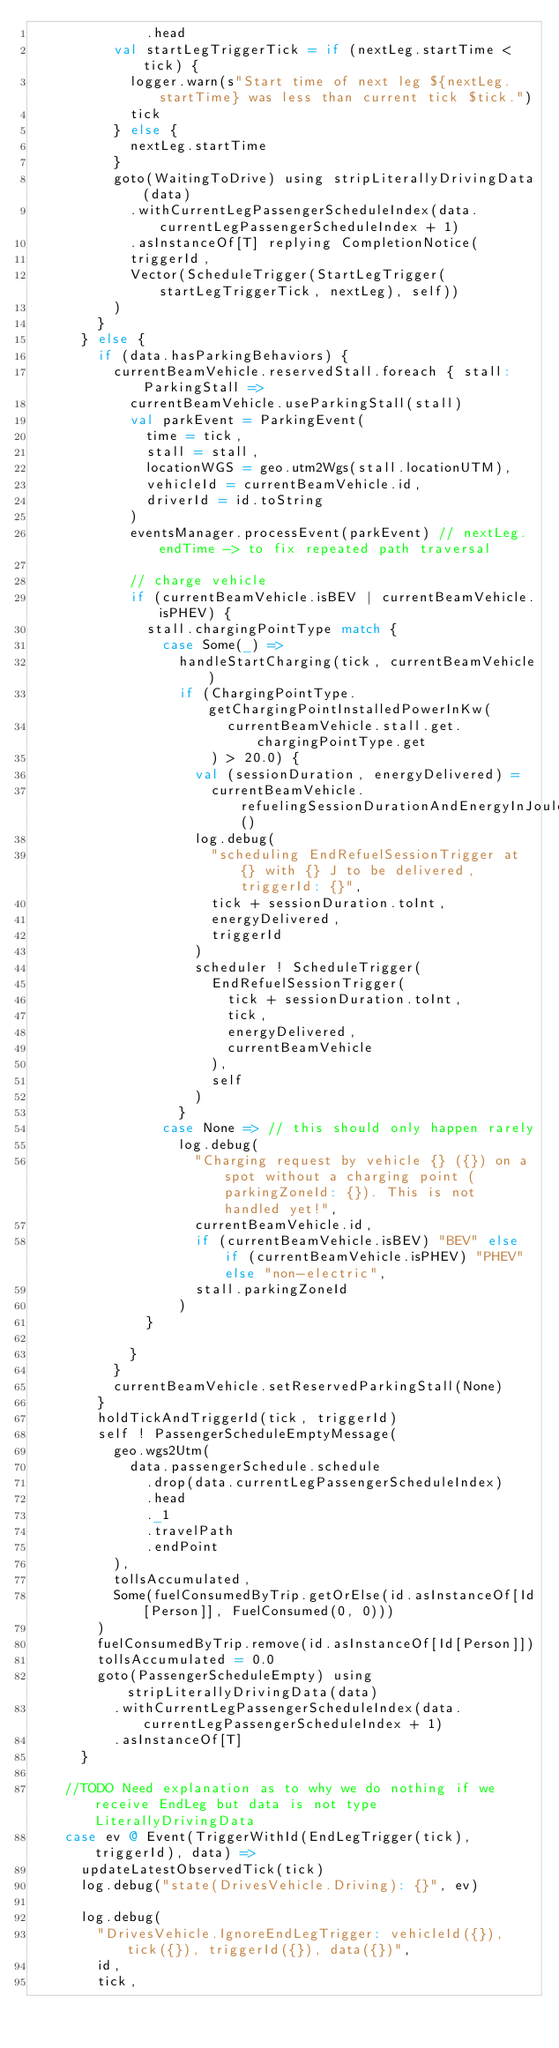<code> <loc_0><loc_0><loc_500><loc_500><_Scala_>              .head
          val startLegTriggerTick = if (nextLeg.startTime < tick) {
            logger.warn(s"Start time of next leg ${nextLeg.startTime} was less than current tick $tick.")
            tick
          } else {
            nextLeg.startTime
          }
          goto(WaitingToDrive) using stripLiterallyDrivingData(data)
            .withCurrentLegPassengerScheduleIndex(data.currentLegPassengerScheduleIndex + 1)
            .asInstanceOf[T] replying CompletionNotice(
            triggerId,
            Vector(ScheduleTrigger(StartLegTrigger(startLegTriggerTick, nextLeg), self))
          )
        }
      } else {
        if (data.hasParkingBehaviors) {
          currentBeamVehicle.reservedStall.foreach { stall: ParkingStall =>
            currentBeamVehicle.useParkingStall(stall)
            val parkEvent = ParkingEvent(
              time = tick,
              stall = stall,
              locationWGS = geo.utm2Wgs(stall.locationUTM),
              vehicleId = currentBeamVehicle.id,
              driverId = id.toString
            )
            eventsManager.processEvent(parkEvent) // nextLeg.endTime -> to fix repeated path traversal

            // charge vehicle
            if (currentBeamVehicle.isBEV | currentBeamVehicle.isPHEV) {
              stall.chargingPointType match {
                case Some(_) =>
                  handleStartCharging(tick, currentBeamVehicle)
                  if (ChargingPointType.getChargingPointInstalledPowerInKw(
                        currentBeamVehicle.stall.get.chargingPointType.get
                      ) > 20.0) {
                    val (sessionDuration, energyDelivered) =
                      currentBeamVehicle.refuelingSessionDurationAndEnergyInJoules()
                    log.debug(
                      "scheduling EndRefuelSessionTrigger at {} with {} J to be delivered, triggerId: {}",
                      tick + sessionDuration.toInt,
                      energyDelivered,
                      triggerId
                    )
                    scheduler ! ScheduleTrigger(
                      EndRefuelSessionTrigger(
                        tick + sessionDuration.toInt,
                        tick,
                        energyDelivered,
                        currentBeamVehicle
                      ),
                      self
                    )
                  }
                case None => // this should only happen rarely
                  log.debug(
                    "Charging request by vehicle {} ({}) on a spot without a charging point (parkingZoneId: {}). This is not handled yet!",
                    currentBeamVehicle.id,
                    if (currentBeamVehicle.isBEV) "BEV" else if (currentBeamVehicle.isPHEV) "PHEV" else "non-electric",
                    stall.parkingZoneId
                  )
              }

            }
          }
          currentBeamVehicle.setReservedParkingStall(None)
        }
        holdTickAndTriggerId(tick, triggerId)
        self ! PassengerScheduleEmptyMessage(
          geo.wgs2Utm(
            data.passengerSchedule.schedule
              .drop(data.currentLegPassengerScheduleIndex)
              .head
              ._1
              .travelPath
              .endPoint
          ),
          tollsAccumulated,
          Some(fuelConsumedByTrip.getOrElse(id.asInstanceOf[Id[Person]], FuelConsumed(0, 0)))
        )
        fuelConsumedByTrip.remove(id.asInstanceOf[Id[Person]])
        tollsAccumulated = 0.0
        goto(PassengerScheduleEmpty) using stripLiterallyDrivingData(data)
          .withCurrentLegPassengerScheduleIndex(data.currentLegPassengerScheduleIndex + 1)
          .asInstanceOf[T]
      }

    //TODO Need explanation as to why we do nothing if we receive EndLeg but data is not type LiterallyDrivingData
    case ev @ Event(TriggerWithId(EndLegTrigger(tick), triggerId), data) =>
      updateLatestObservedTick(tick)
      log.debug("state(DrivesVehicle.Driving): {}", ev)

      log.debug(
        "DrivesVehicle.IgnoreEndLegTrigger: vehicleId({}), tick({}), triggerId({}), data({})",
        id,
        tick,</code> 